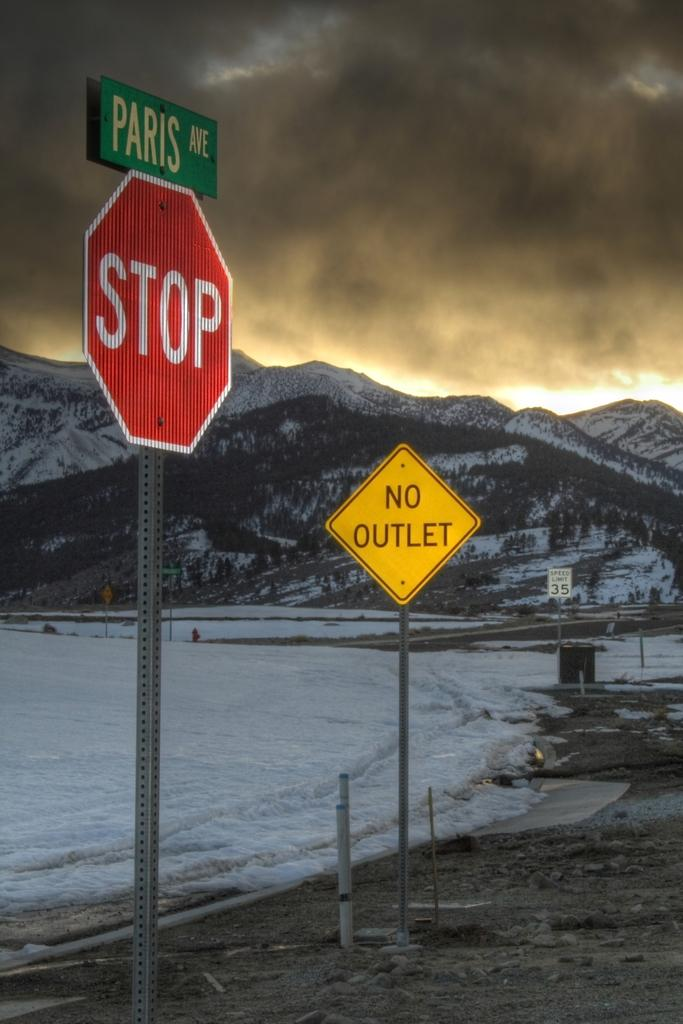<image>
Write a terse but informative summary of the picture. A Stop sign and a No Outlet sign are in the foreground of a snowy mountain. 